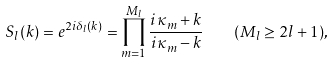<formula> <loc_0><loc_0><loc_500><loc_500>S _ { l } ( k ) = e ^ { 2 i \delta _ { l } ( k ) } = \prod _ { m = 1 } ^ { M _ { l } } \frac { i \kappa _ { m } + k } { i \kappa _ { m } - k } \quad ( M _ { l } \geq 2 l + 1 ) ,</formula> 